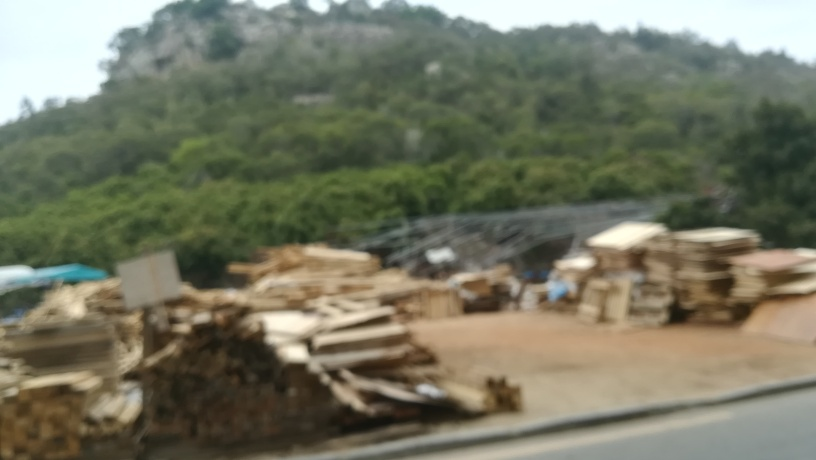Can you describe the setting of this image? The image depicts an outdoor scene that is notably blurred. Despite the lack of clarity, we can infer the presence of stacked objects resembling wood and a natural backdrop that could be a hill or forested area. 